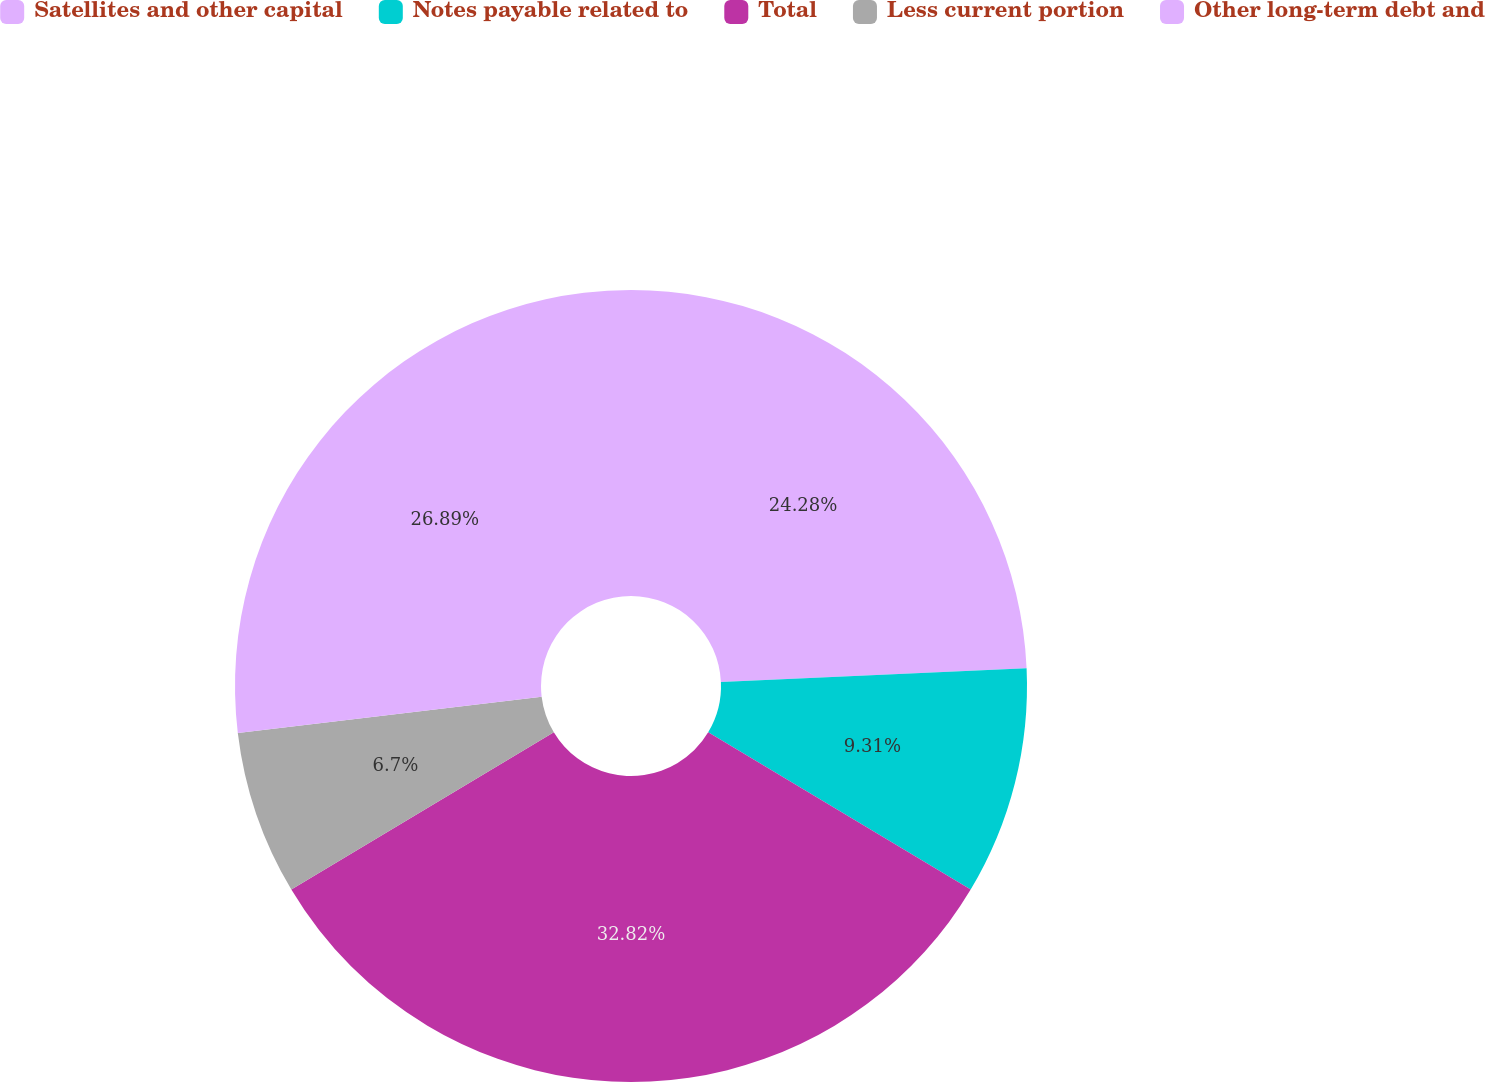<chart> <loc_0><loc_0><loc_500><loc_500><pie_chart><fcel>Satellites and other capital<fcel>Notes payable related to<fcel>Total<fcel>Less current portion<fcel>Other long-term debt and<nl><fcel>24.28%<fcel>9.31%<fcel>32.81%<fcel>6.7%<fcel>26.89%<nl></chart> 